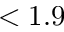<formula> <loc_0><loc_0><loc_500><loc_500>< 1 . 9</formula> 